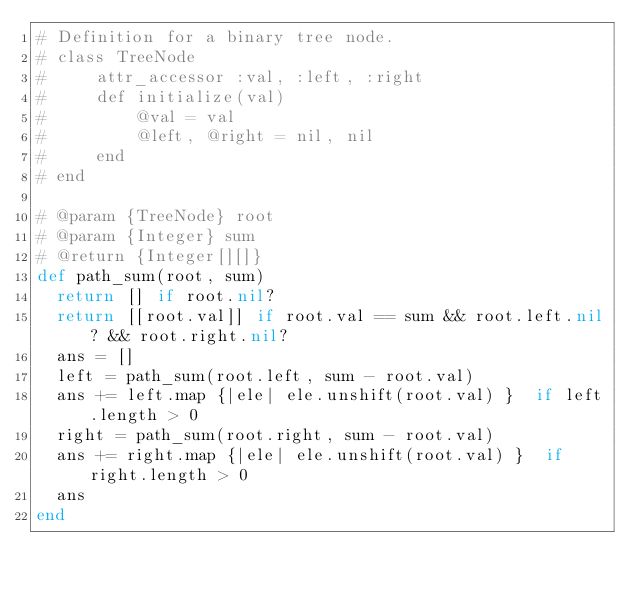<code> <loc_0><loc_0><loc_500><loc_500><_Ruby_># Definition for a binary tree node.
# class TreeNode
#     attr_accessor :val, :left, :right
#     def initialize(val)
#         @val = val
#         @left, @right = nil, nil
#     end
# end

# @param {TreeNode} root
# @param {Integer} sum
# @return {Integer[][]}
def path_sum(root, sum)
  return [] if root.nil?
  return [[root.val]] if root.val == sum && root.left.nil? && root.right.nil?
  ans = []
  left = path_sum(root.left, sum - root.val)
  ans += left.map {|ele| ele.unshift(root.val) }  if left.length > 0
  right = path_sum(root.right, sum - root.val)
  ans += right.map {|ele| ele.unshift(root.val) }  if right.length > 0
  ans
end
</code> 